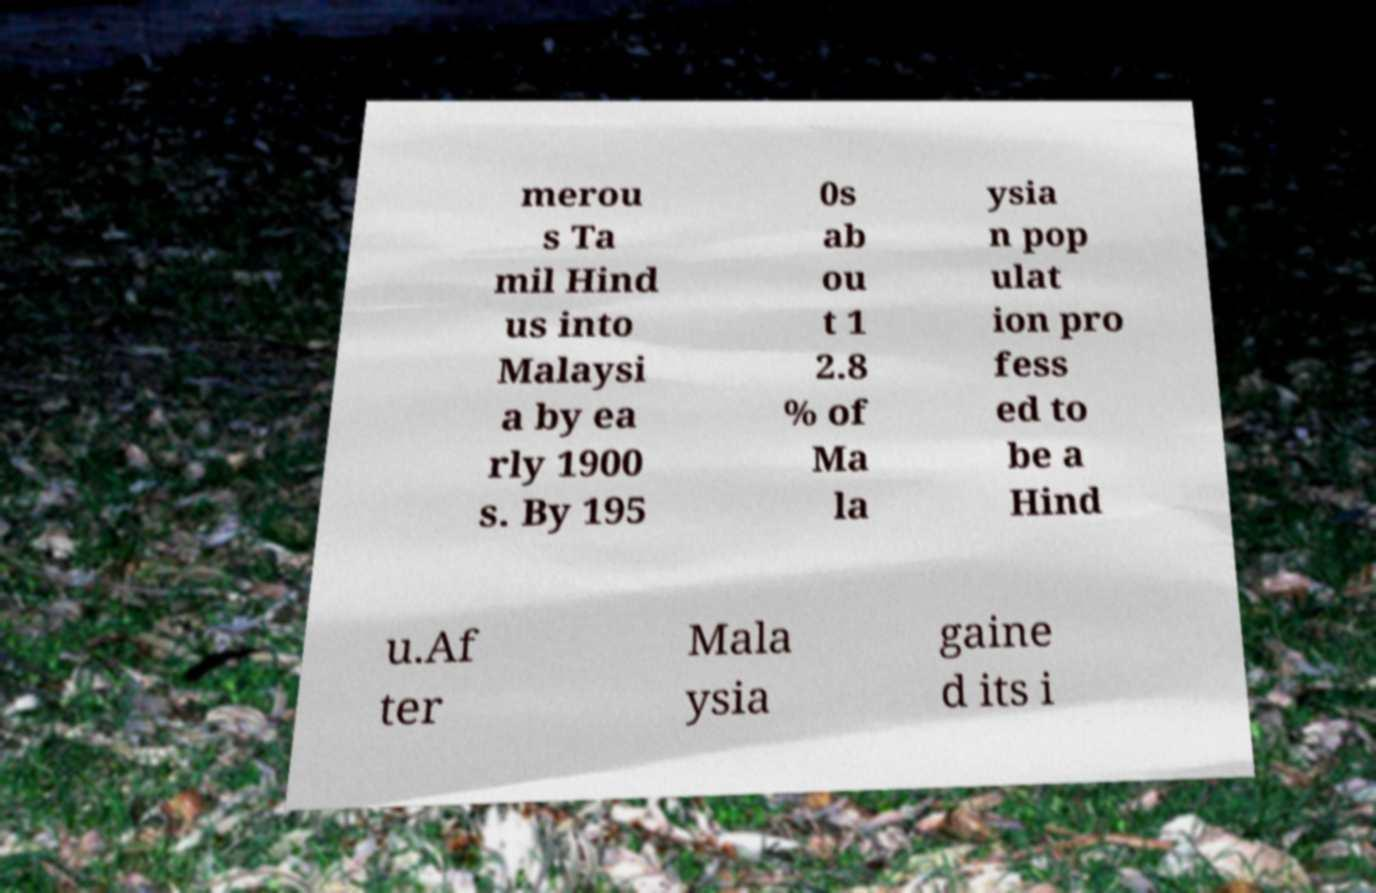Can you accurately transcribe the text from the provided image for me? merou s Ta mil Hind us into Malaysi a by ea rly 1900 s. By 195 0s ab ou t 1 2.8 % of Ma la ysia n pop ulat ion pro fess ed to be a Hind u.Af ter Mala ysia gaine d its i 